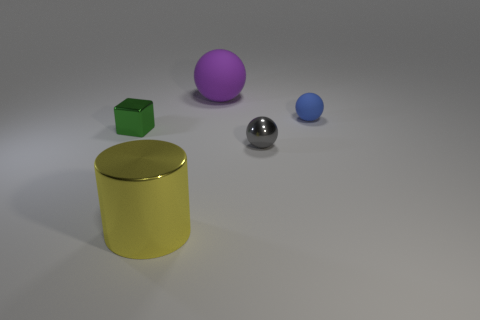There is a metallic thing that is to the right of the yellow cylinder; what is its color?
Offer a very short reply. Gray. There is a object on the right side of the tiny object in front of the green metal cube; what is it made of?
Ensure brevity in your answer.  Rubber. Is the number of rubber things that are in front of the gray metal sphere less than the number of blue balls that are in front of the blue thing?
Your response must be concise. No. What number of purple objects are tiny shiny cubes or tiny balls?
Provide a short and direct response. 0. Are there the same number of blue balls that are to the left of the small green cube and tiny green cubes?
Keep it short and to the point. No. How many objects are either small blue matte spheres or tiny things that are in front of the tiny rubber thing?
Make the answer very short. 3. Does the cube have the same color as the tiny rubber ball?
Provide a succinct answer. No. Is there a small blue ball that has the same material as the large cylinder?
Keep it short and to the point. No. What color is the tiny matte object that is the same shape as the big purple matte object?
Offer a terse response. Blue. Do the big sphere and the large thing in front of the big purple matte ball have the same material?
Give a very brief answer. No. 